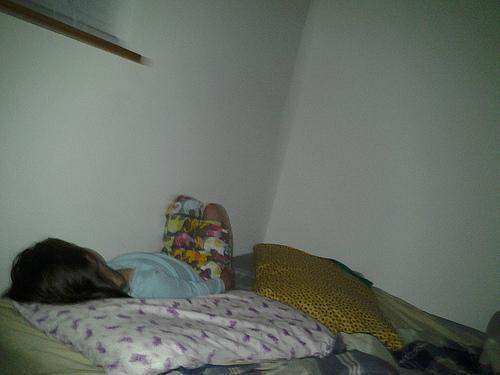How many people are lying in the bed?
Give a very brief answer. 1. 